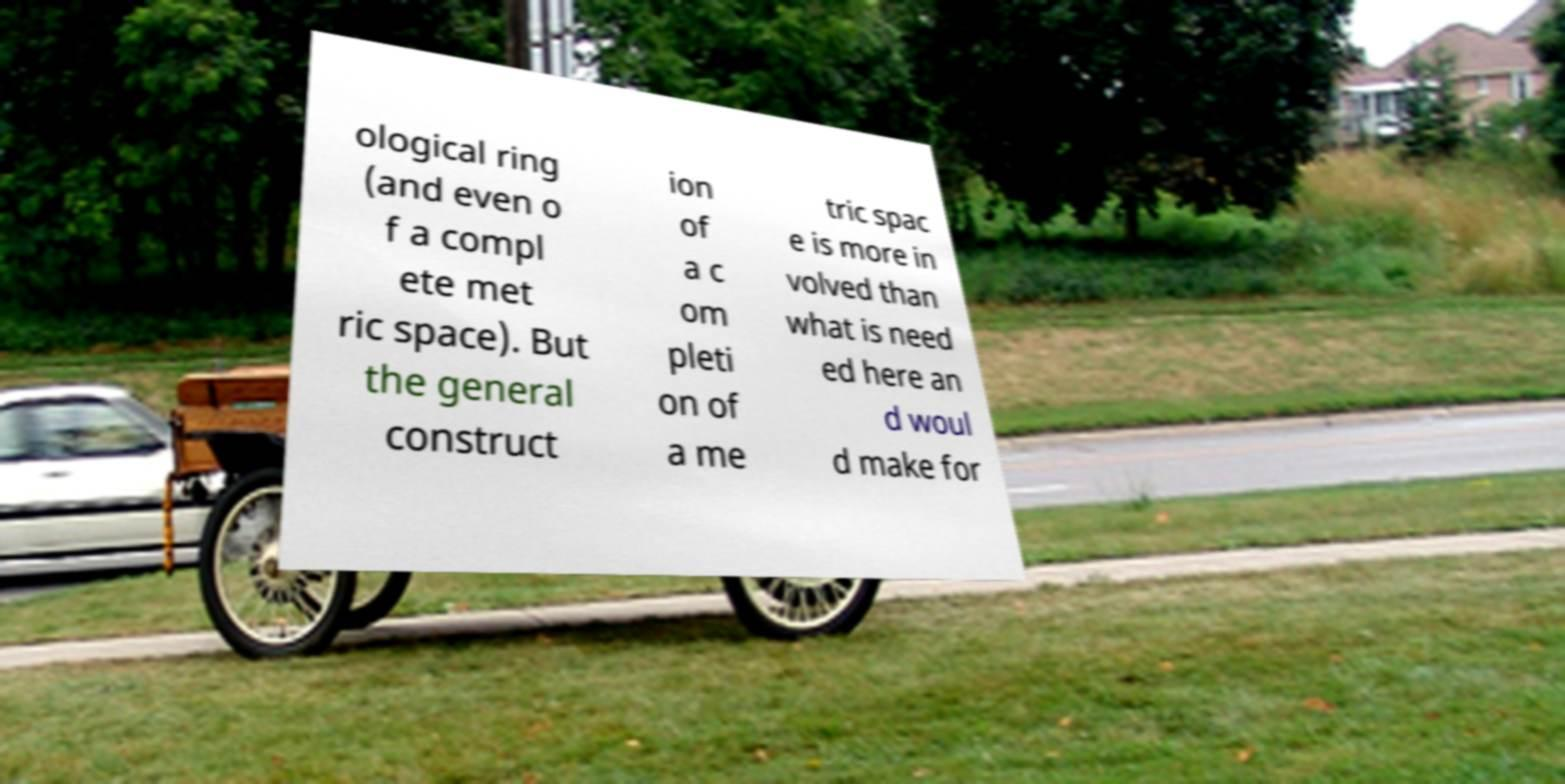Could you assist in decoding the text presented in this image and type it out clearly? ological ring (and even o f a compl ete met ric space). But the general construct ion of a c om pleti on of a me tric spac e is more in volved than what is need ed here an d woul d make for 